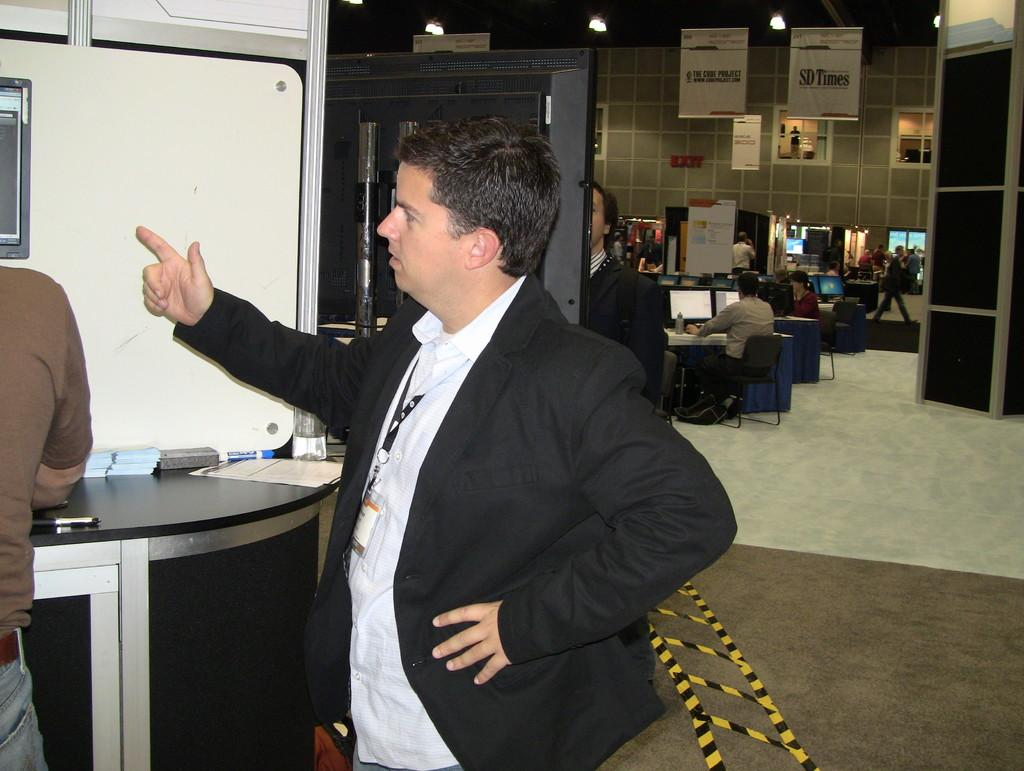What is the person in the image wearing? The person in the image is wearing a suit. What is the person in the suit standing in front of? The person is standing in front of a desktop. Can you describe the other person in the image? There is another person in the left corner of the image. What are the people in the background of the image doing? The people in the background of the image are operating computers. How many kittens can be seen playing with a parcel in the image? There are no kittens or parcels present in the image. What type of amusement is the person in the suit enjoying in the image? The image does not depict any specific amusement or activity that the person in the suit is enjoying. 